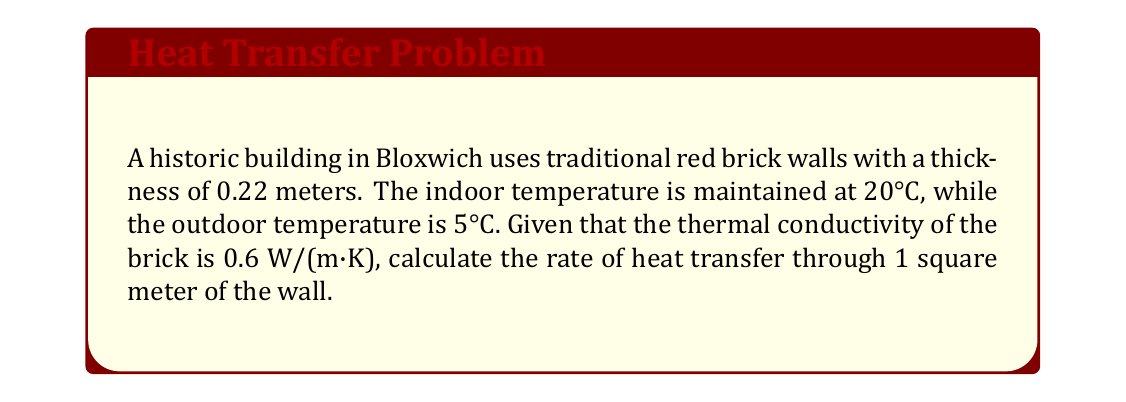Provide a solution to this math problem. To solve this problem, we'll use Fourier's law of heat conduction:

$$q = -k \frac{dT}{dx}$$

Where:
$q$ = heat flux (W/m²)
$k$ = thermal conductivity (W/(m·K))
$\frac{dT}{dx}$ = temperature gradient (K/m)

For a wall with constant thermal conductivity and steady-state conditions, we can simplify this to:

$$q = k \frac{\Delta T}{L}$$

Where:
$\Delta T$ = temperature difference (K)
$L$ = wall thickness (m)

Given:
$k = 0.6$ W/(m·K)
$\Delta T = 20°C - 5°C = 15°C = 15$ K
$L = 0.22$ m

Substituting these values:

$$q = 0.6 \frac{15}{0.22}$$

$$q = 0.6 \cdot 68.18$$

$$q = 40.91 \text{ W/m²}$$

This result represents the rate of heat transfer through 1 square meter of the wall.
Answer: 40.91 W/m² 